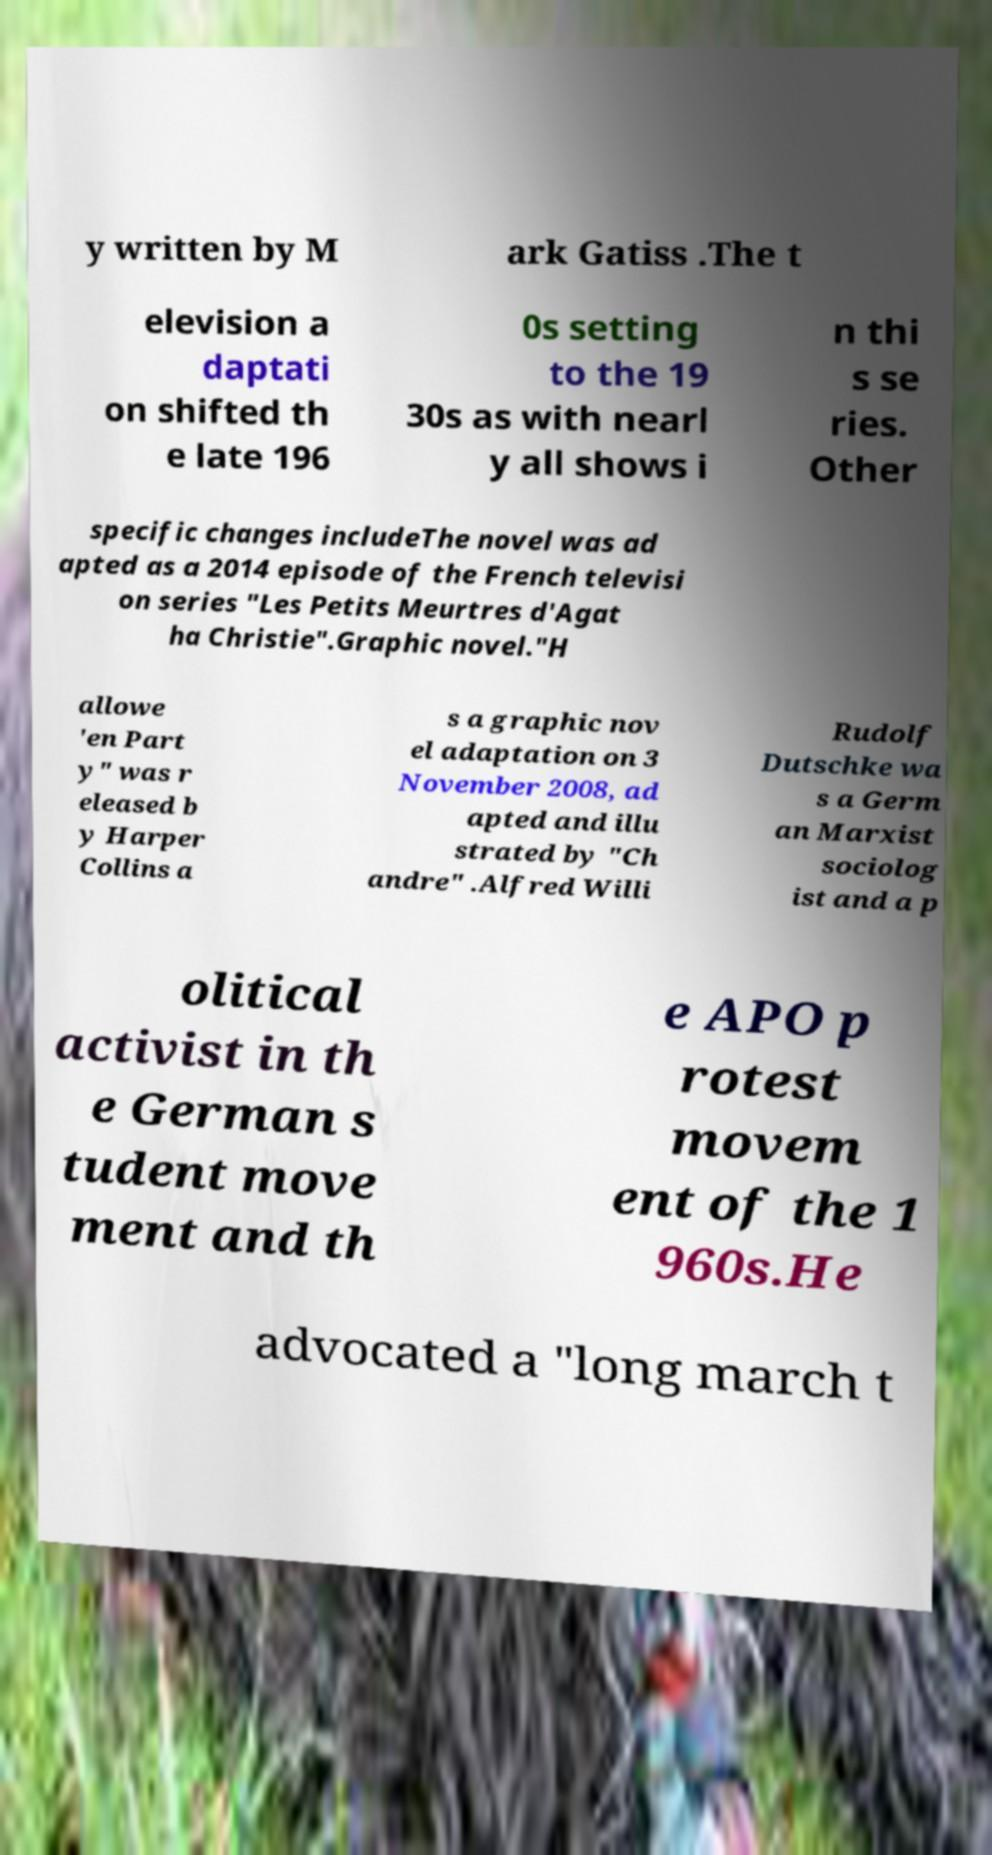Can you read and provide the text displayed in the image?This photo seems to have some interesting text. Can you extract and type it out for me? y written by M ark Gatiss .The t elevision a daptati on shifted th e late 196 0s setting to the 19 30s as with nearl y all shows i n thi s se ries. Other specific changes includeThe novel was ad apted as a 2014 episode of the French televisi on series "Les Petits Meurtres d'Agat ha Christie".Graphic novel."H allowe 'en Part y" was r eleased b y Harper Collins a s a graphic nov el adaptation on 3 November 2008, ad apted and illu strated by "Ch andre" .Alfred Willi Rudolf Dutschke wa s a Germ an Marxist sociolog ist and a p olitical activist in th e German s tudent move ment and th e APO p rotest movem ent of the 1 960s.He advocated a "long march t 